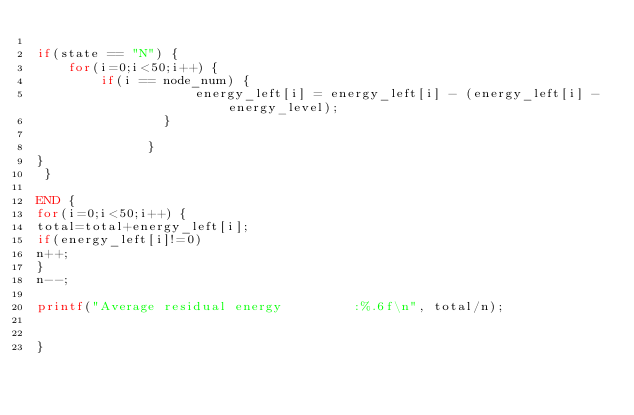<code> <loc_0><loc_0><loc_500><loc_500><_Awk_>
if(state == "N") {
	for(i=0;i<50;i++) {
		if(i == node_num) {
					energy_left[i] = energy_left[i] - (energy_left[i] - energy_level);
				}
			
			  }
}
 }

END {
for(i=0;i<50;i++) {
total=total+energy_left[i];
if(energy_left[i]!=0)
n++;
}
n--;

printf("Average residual energy  		:%.6f\n", total/n);


}
</code> 